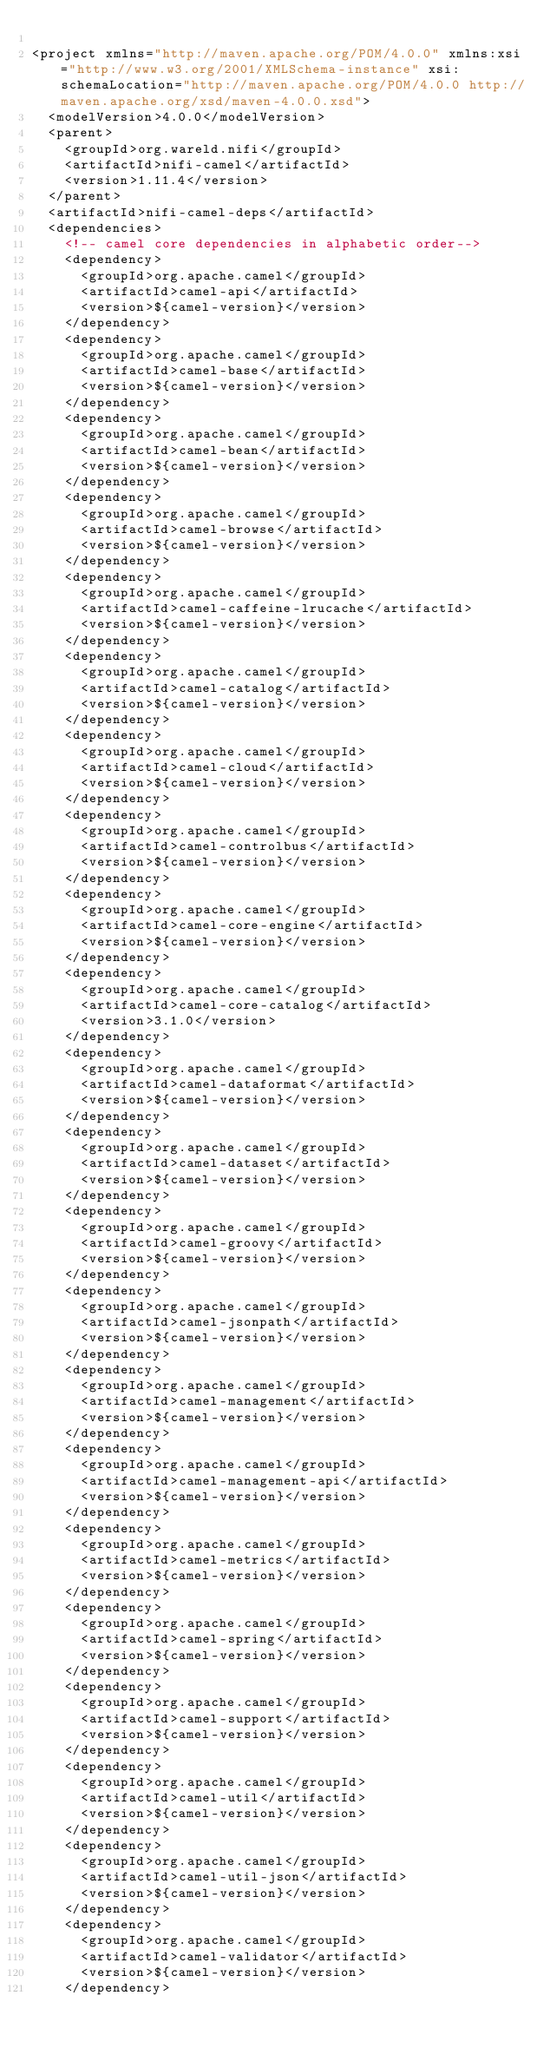<code> <loc_0><loc_0><loc_500><loc_500><_XML_>
<project xmlns="http://maven.apache.org/POM/4.0.0" xmlns:xsi="http://www.w3.org/2001/XMLSchema-instance" xsi:schemaLocation="http://maven.apache.org/POM/4.0.0 http://maven.apache.org/xsd/maven-4.0.0.xsd">
  <modelVersion>4.0.0</modelVersion>
  <parent>
    <groupId>org.wareld.nifi</groupId>
    <artifactId>nifi-camel</artifactId>
    <version>1.11.4</version>
  </parent>
  <artifactId>nifi-camel-deps</artifactId>
  <dependencies>
    <!-- camel core dependencies in alphabetic order-->
    <dependency>
      <groupId>org.apache.camel</groupId>
      <artifactId>camel-api</artifactId>
      <version>${camel-version}</version>
    </dependency>
    <dependency>
      <groupId>org.apache.camel</groupId>
      <artifactId>camel-base</artifactId>
      <version>${camel-version}</version>
    </dependency>
    <dependency>
      <groupId>org.apache.camel</groupId>
      <artifactId>camel-bean</artifactId>
      <version>${camel-version}</version>
    </dependency>
    <dependency>
      <groupId>org.apache.camel</groupId>
      <artifactId>camel-browse</artifactId>
      <version>${camel-version}</version>
    </dependency>
    <dependency>
      <groupId>org.apache.camel</groupId>
      <artifactId>camel-caffeine-lrucache</artifactId>
      <version>${camel-version}</version>
    </dependency>
    <dependency>
      <groupId>org.apache.camel</groupId>
      <artifactId>camel-catalog</artifactId>
      <version>${camel-version}</version>
    </dependency>
    <dependency>
      <groupId>org.apache.camel</groupId>
      <artifactId>camel-cloud</artifactId>
      <version>${camel-version}</version>
    </dependency>
    <dependency>
      <groupId>org.apache.camel</groupId>
      <artifactId>camel-controlbus</artifactId>
      <version>${camel-version}</version>
    </dependency>
    <dependency>
      <groupId>org.apache.camel</groupId>
      <artifactId>camel-core-engine</artifactId>
      <version>${camel-version}</version>
    </dependency>
    <dependency>
      <groupId>org.apache.camel</groupId>
      <artifactId>camel-core-catalog</artifactId>
      <version>3.1.0</version>
    </dependency>
    <dependency>
      <groupId>org.apache.camel</groupId>
      <artifactId>camel-dataformat</artifactId>
      <version>${camel-version}</version>
    </dependency>
    <dependency>
      <groupId>org.apache.camel</groupId>
      <artifactId>camel-dataset</artifactId>
      <version>${camel-version}</version>
    </dependency>
    <dependency>
      <groupId>org.apache.camel</groupId>
      <artifactId>camel-groovy</artifactId>
      <version>${camel-version}</version>
    </dependency>
    <dependency>
      <groupId>org.apache.camel</groupId>
      <artifactId>camel-jsonpath</artifactId>
      <version>${camel-version}</version>
    </dependency>
    <dependency>
      <groupId>org.apache.camel</groupId>
      <artifactId>camel-management</artifactId>
      <version>${camel-version}</version>
    </dependency>
    <dependency>
      <groupId>org.apache.camel</groupId>
      <artifactId>camel-management-api</artifactId>
      <version>${camel-version}</version>
    </dependency>
    <dependency>
      <groupId>org.apache.camel</groupId>
      <artifactId>camel-metrics</artifactId>
      <version>${camel-version}</version>
    </dependency>
    <dependency>
      <groupId>org.apache.camel</groupId>
      <artifactId>camel-spring</artifactId>
      <version>${camel-version}</version>
    </dependency>
    <dependency>
      <groupId>org.apache.camel</groupId>
      <artifactId>camel-support</artifactId>
      <version>${camel-version}</version>
    </dependency>
    <dependency>
      <groupId>org.apache.camel</groupId>
      <artifactId>camel-util</artifactId>
      <version>${camel-version}</version>
    </dependency>
    <dependency>
      <groupId>org.apache.camel</groupId>
      <artifactId>camel-util-json</artifactId>
      <version>${camel-version}</version>
    </dependency>
    <dependency>
      <groupId>org.apache.camel</groupId>
      <artifactId>camel-validator</artifactId>
      <version>${camel-version}</version>
    </dependency></code> 